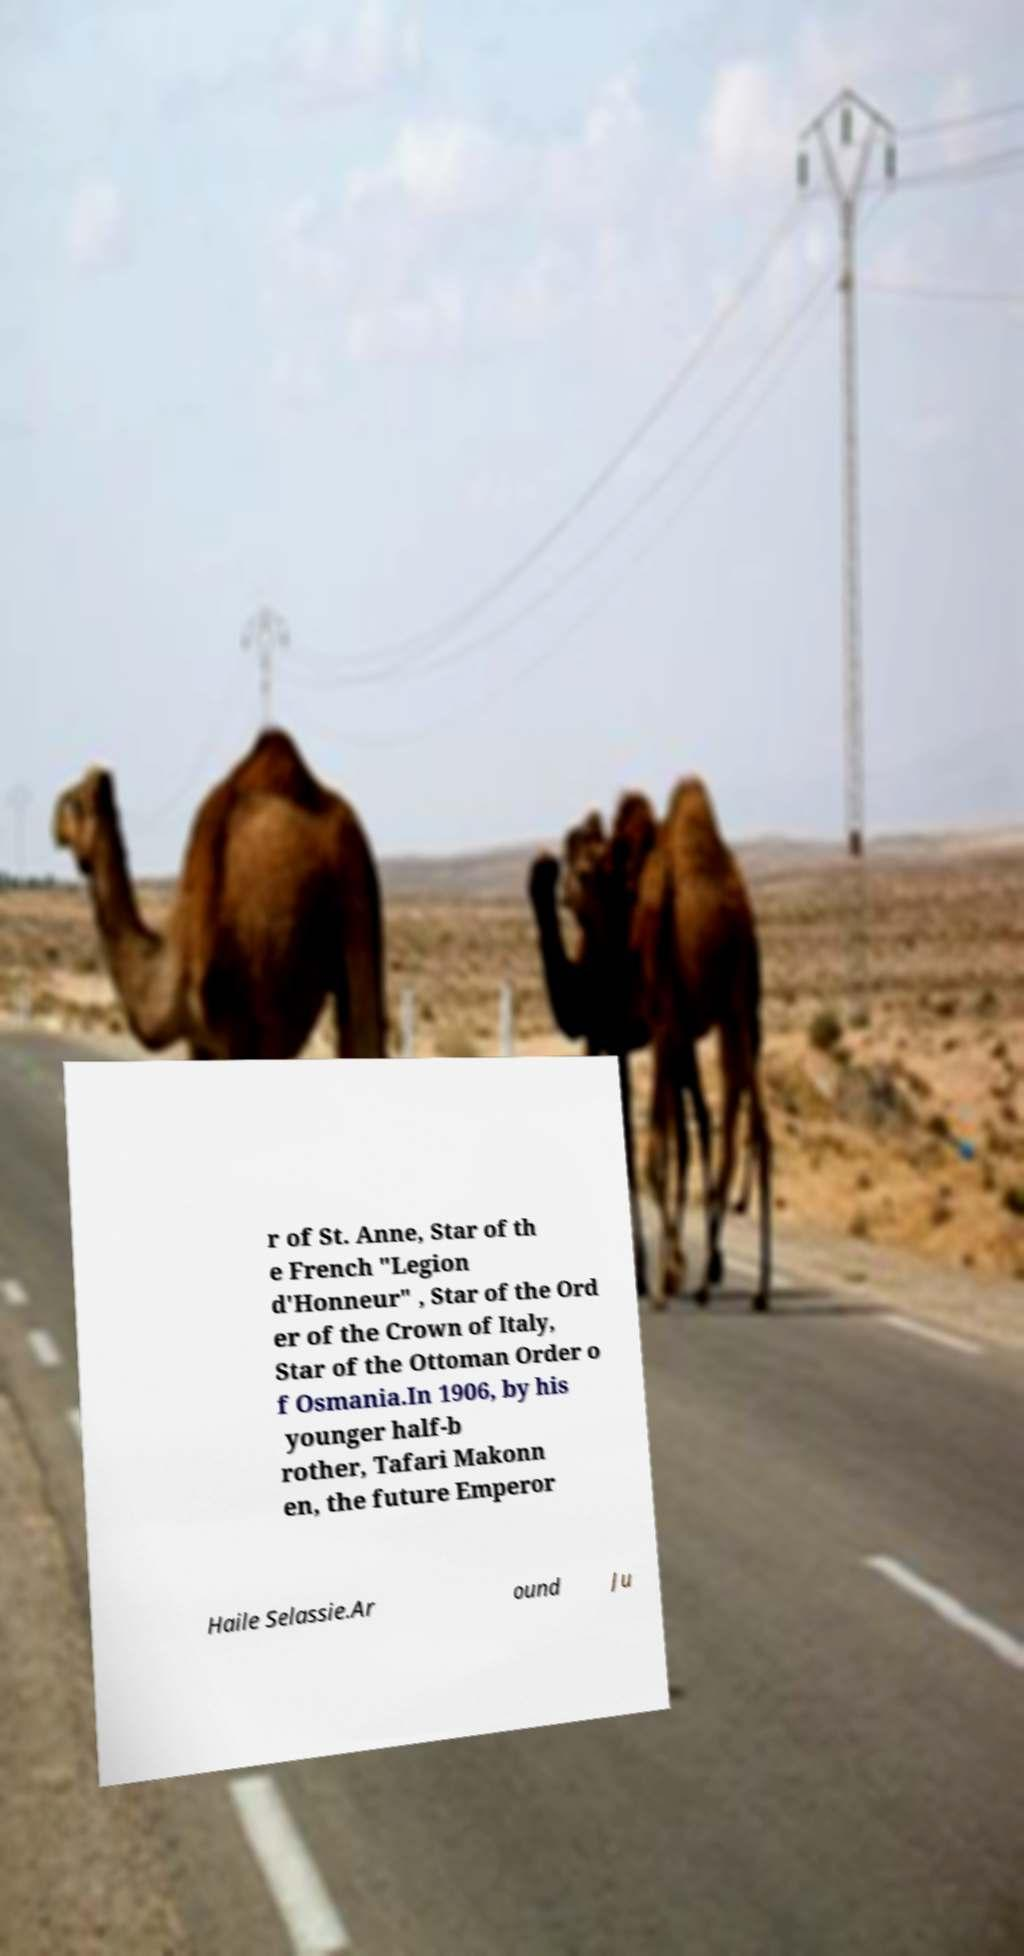For documentation purposes, I need the text within this image transcribed. Could you provide that? r of St. Anne, Star of th e French "Legion d'Honneur" , Star of the Ord er of the Crown of Italy, Star of the Ottoman Order o f Osmania.In 1906, by his younger half-b rother, Tafari Makonn en, the future Emperor Haile Selassie.Ar ound Ju 